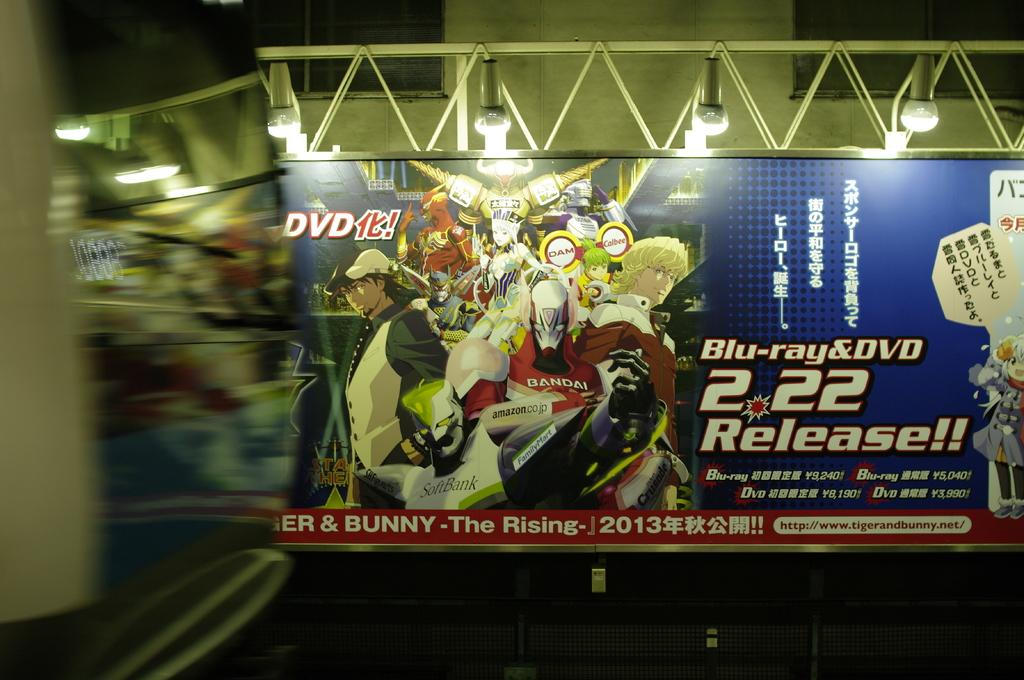<image>
Create a compact narrative representing the image presented. a billboard with the word blu-ray on it 